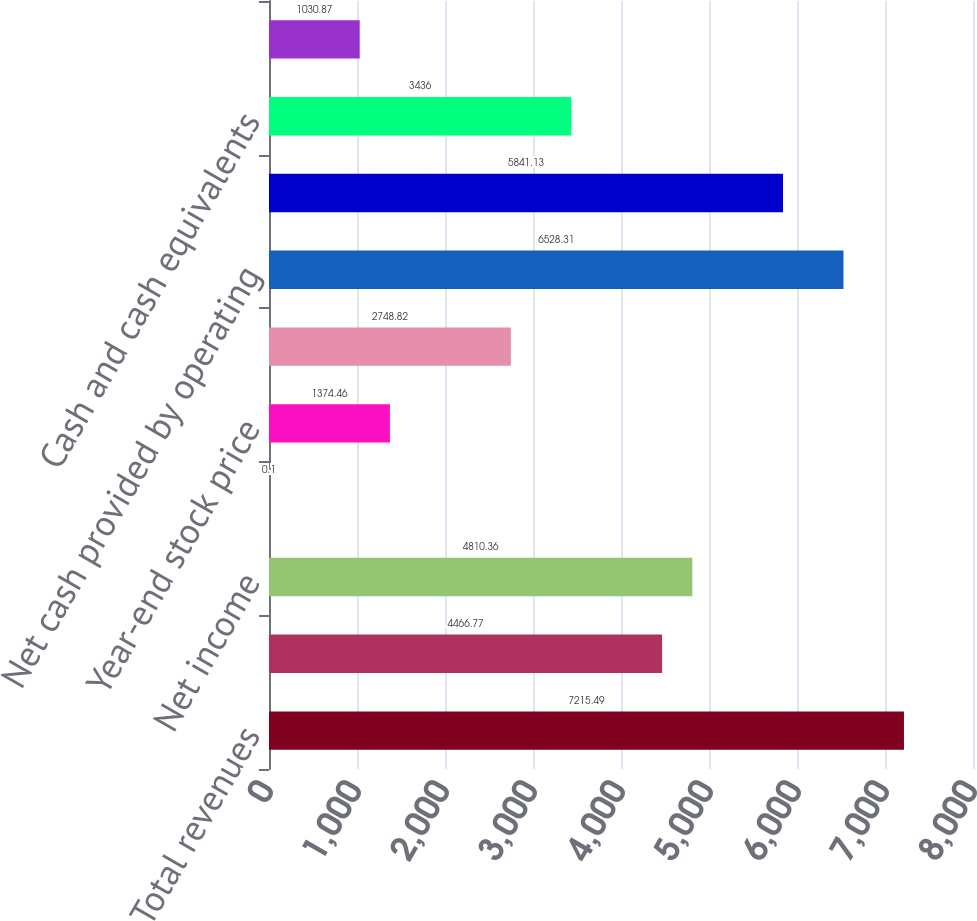Convert chart to OTSL. <chart><loc_0><loc_0><loc_500><loc_500><bar_chart><fcel>Total revenues<fcel>Income from continuing<fcel>Net income<fcel>Cash dividends<fcel>Year-end stock price<fcel>Basic weighted average shares<fcel>Net cash provided by operating<fcel>Additions to property plant<fcel>Cash and cash equivalents<fcel>Commodity derivative<nl><fcel>7215.49<fcel>4466.77<fcel>4810.36<fcel>0.1<fcel>1374.46<fcel>2748.82<fcel>6528.31<fcel>5841.13<fcel>3436<fcel>1030.87<nl></chart> 